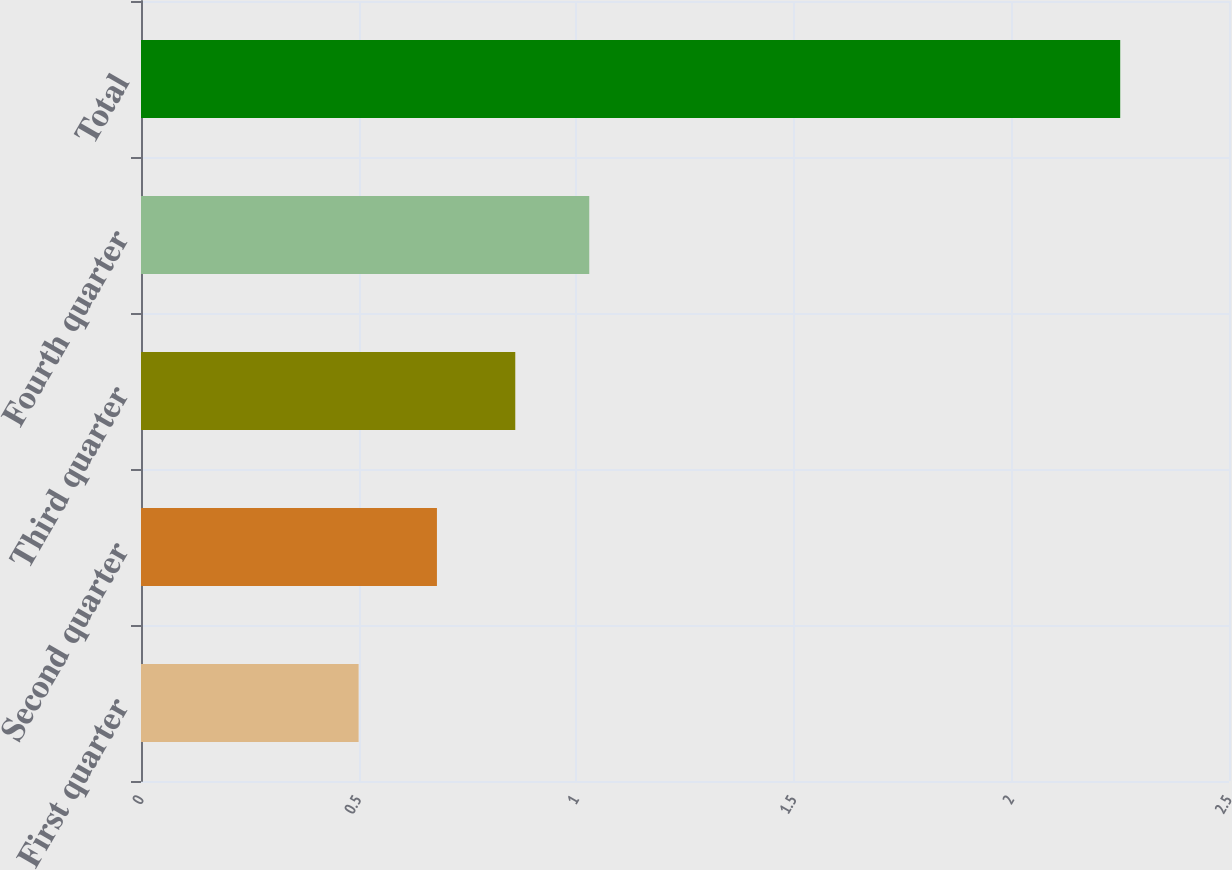Convert chart. <chart><loc_0><loc_0><loc_500><loc_500><bar_chart><fcel>First quarter<fcel>Second quarter<fcel>Third quarter<fcel>Fourth quarter<fcel>Total<nl><fcel>0.5<fcel>0.68<fcel>0.86<fcel>1.03<fcel>2.25<nl></chart> 